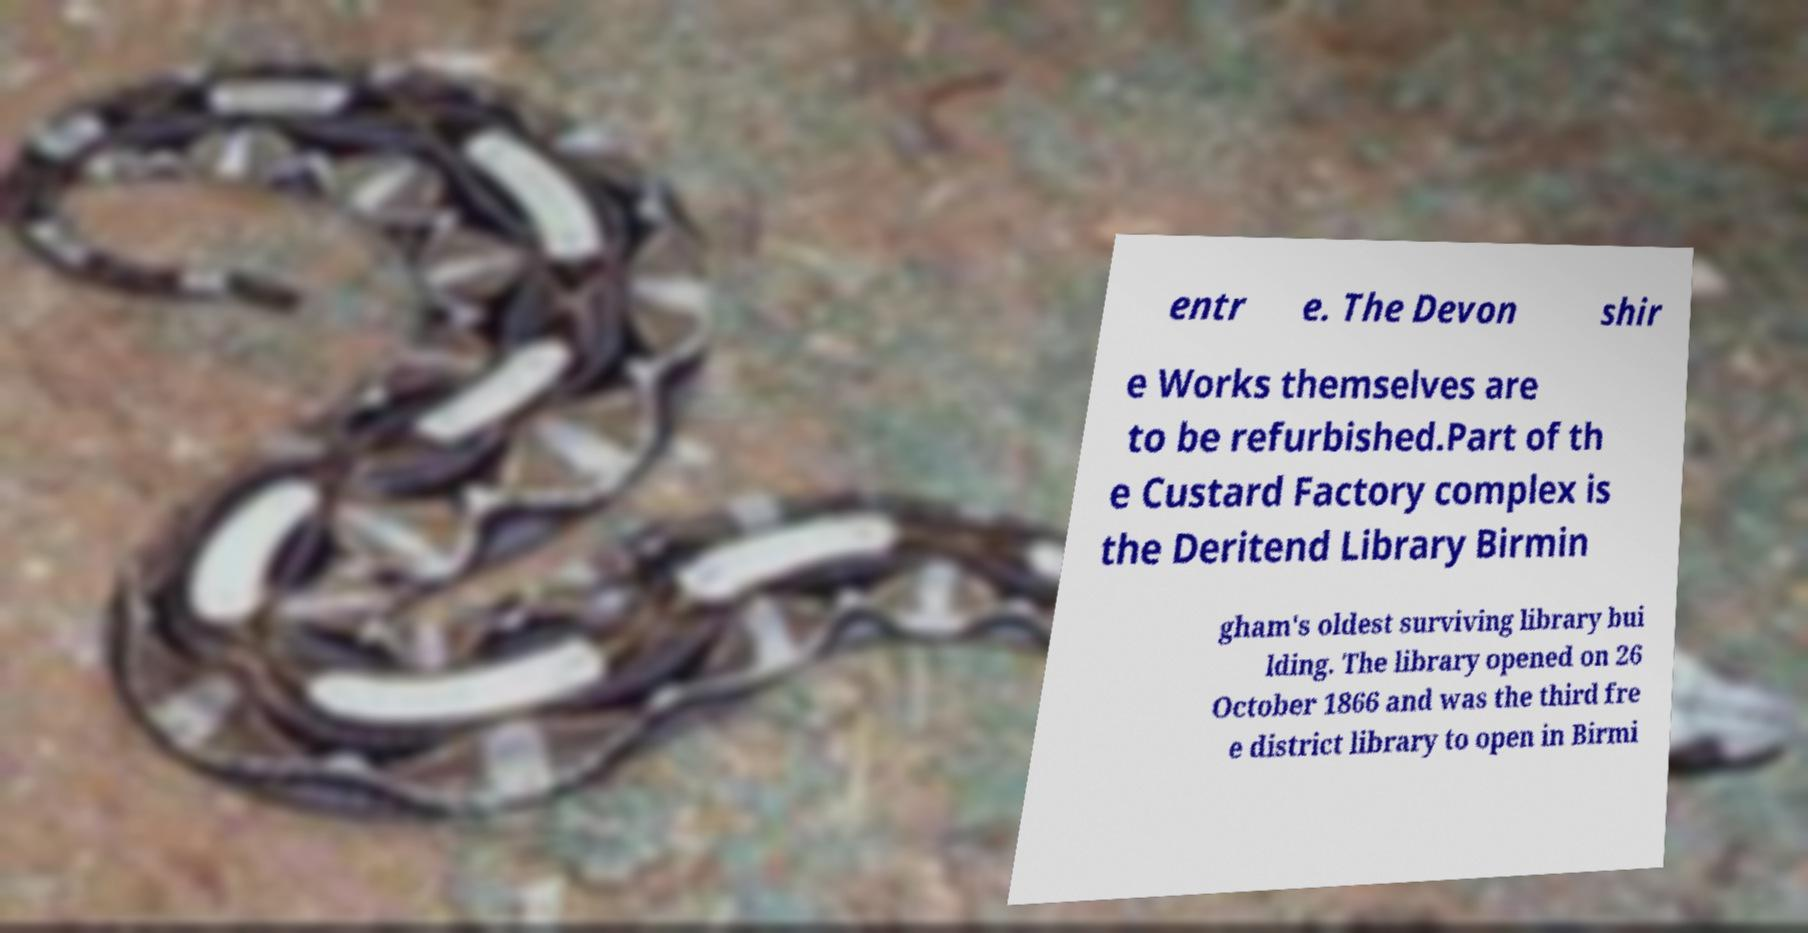Can you read and provide the text displayed in the image?This photo seems to have some interesting text. Can you extract and type it out for me? entr e. The Devon shir e Works themselves are to be refurbished.Part of th e Custard Factory complex is the Deritend Library Birmin gham's oldest surviving library bui lding. The library opened on 26 October 1866 and was the third fre e district library to open in Birmi 